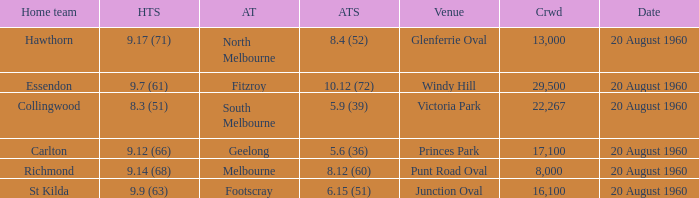What is the venue when Geelong is the away team? Princes Park. 